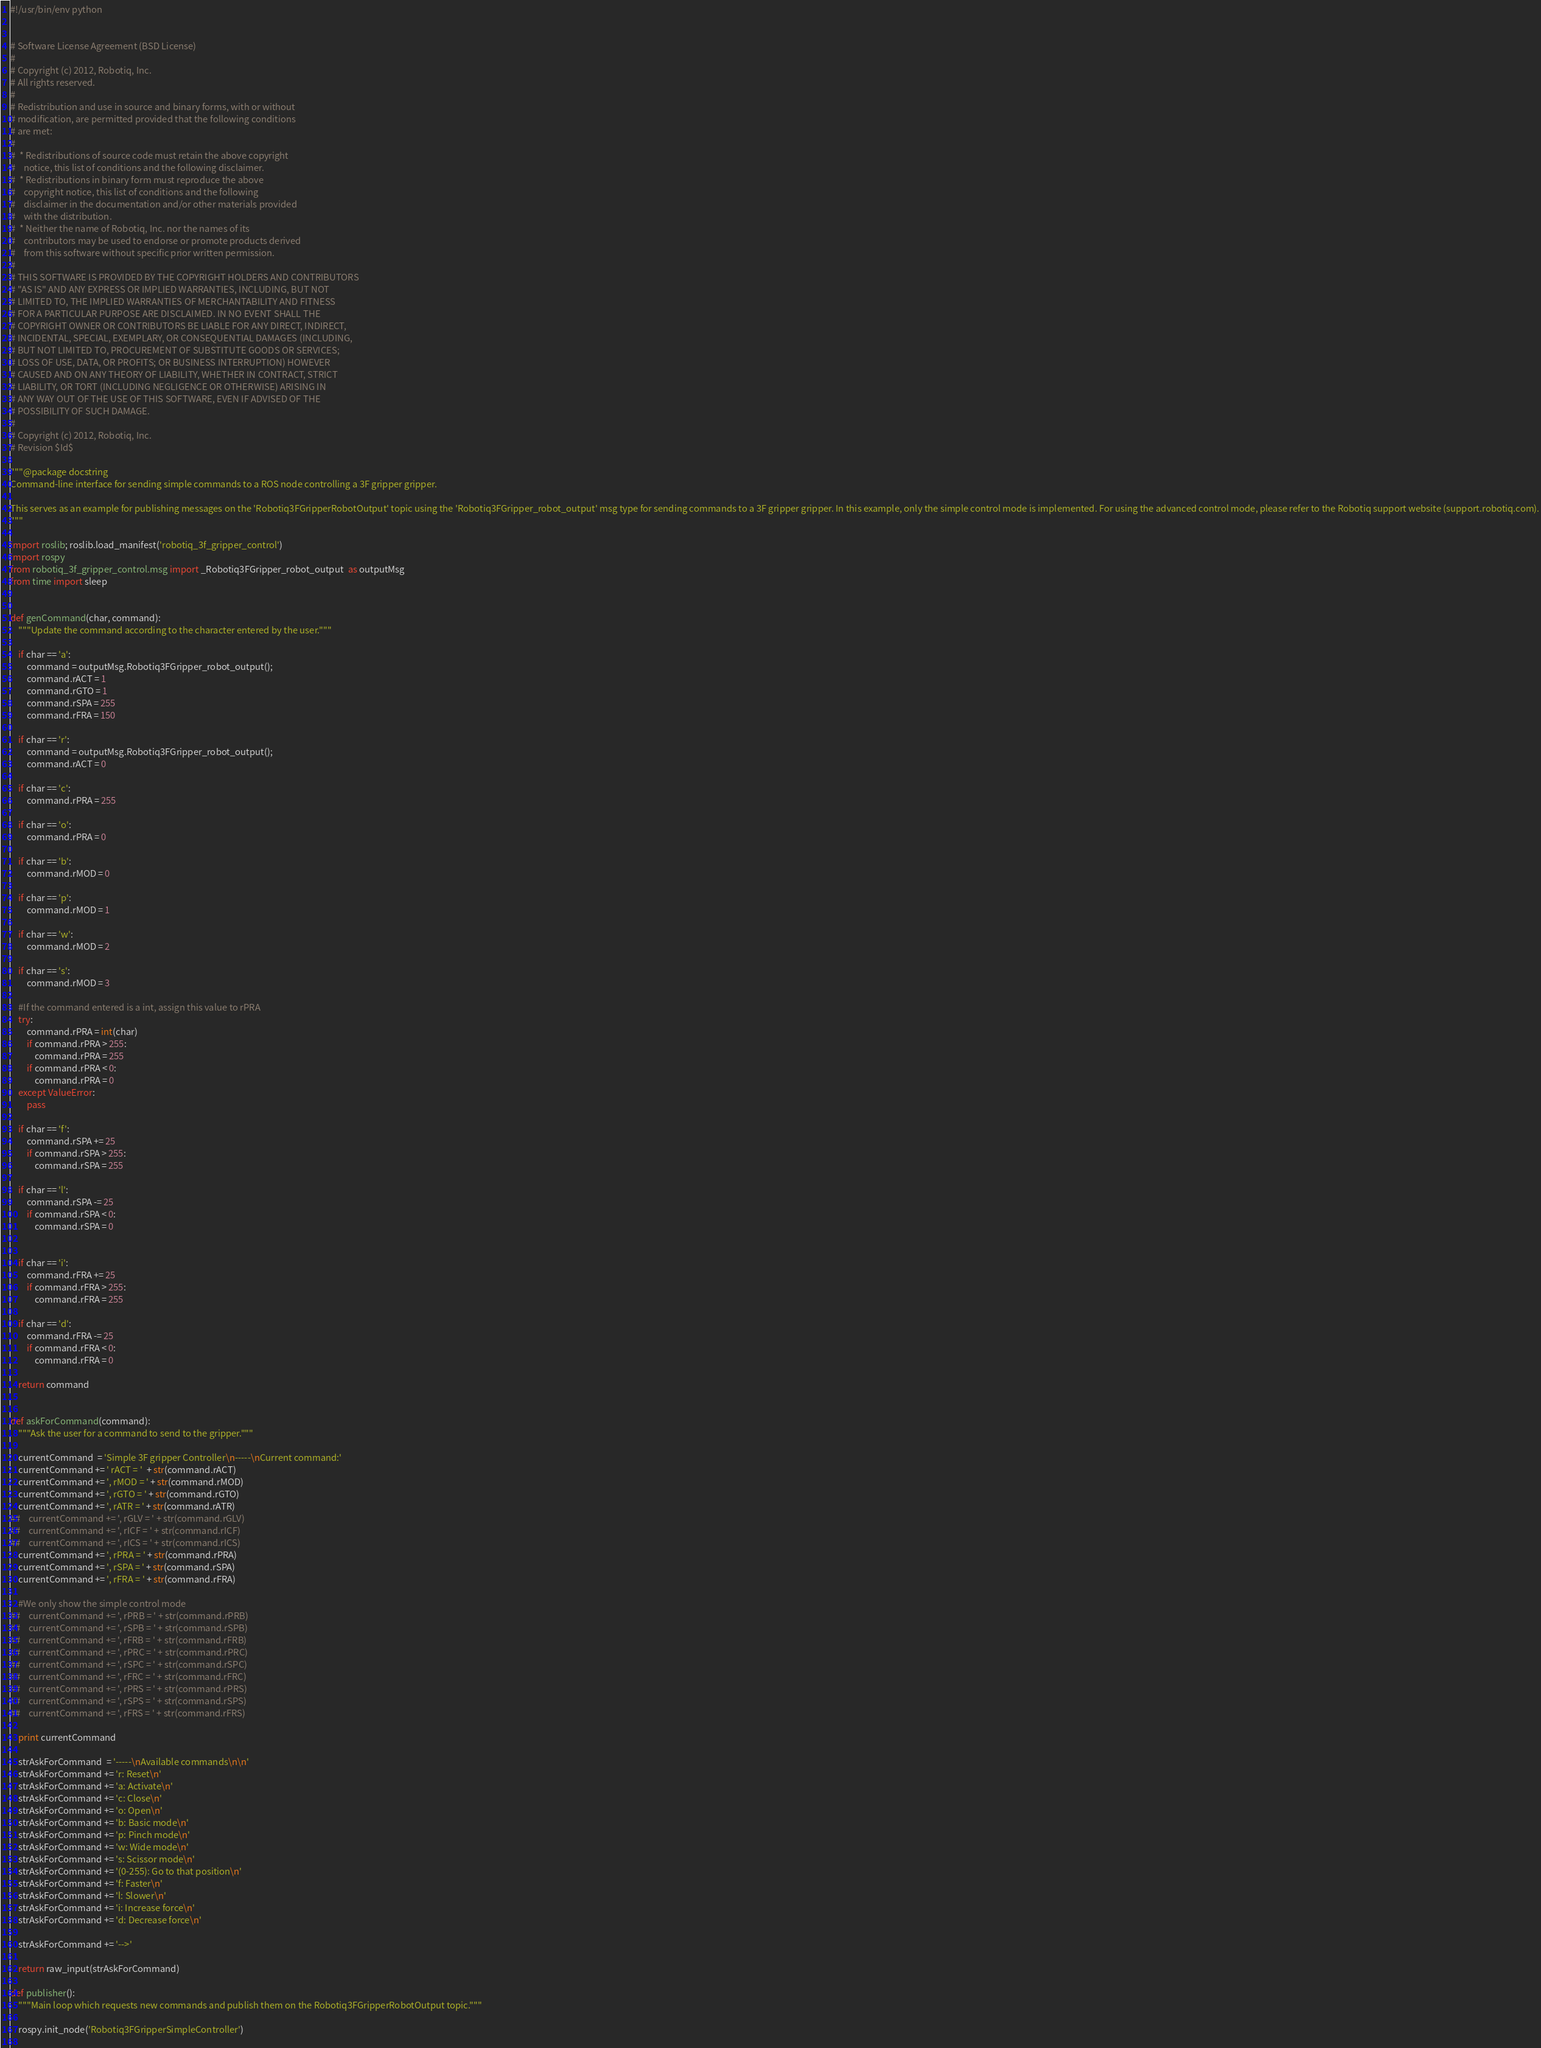Convert code to text. <code><loc_0><loc_0><loc_500><loc_500><_Python_>#!/usr/bin/env python


# Software License Agreement (BSD License)
#
# Copyright (c) 2012, Robotiq, Inc.
# All rights reserved.
#
# Redistribution and use in source and binary forms, with or without
# modification, are permitted provided that the following conditions
# are met:
#
#  * Redistributions of source code must retain the above copyright
#    notice, this list of conditions and the following disclaimer.
#  * Redistributions in binary form must reproduce the above
#    copyright notice, this list of conditions and the following
#    disclaimer in the documentation and/or other materials provided
#    with the distribution.
#  * Neither the name of Robotiq, Inc. nor the names of its
#    contributors may be used to endorse or promote products derived
#    from this software without specific prior written permission.
#
# THIS SOFTWARE IS PROVIDED BY THE COPYRIGHT HOLDERS AND CONTRIBUTORS
# "AS IS" AND ANY EXPRESS OR IMPLIED WARRANTIES, INCLUDING, BUT NOT
# LIMITED TO, THE IMPLIED WARRANTIES OF MERCHANTABILITY AND FITNESS
# FOR A PARTICULAR PURPOSE ARE DISCLAIMED. IN NO EVENT SHALL THE
# COPYRIGHT OWNER OR CONTRIBUTORS BE LIABLE FOR ANY DIRECT, INDIRECT,
# INCIDENTAL, SPECIAL, EXEMPLARY, OR CONSEQUENTIAL DAMAGES (INCLUDING,
# BUT NOT LIMITED TO, PROCUREMENT OF SUBSTITUTE GOODS OR SERVICES;
# LOSS OF USE, DATA, OR PROFITS; OR BUSINESS INTERRUPTION) HOWEVER
# CAUSED AND ON ANY THEORY OF LIABILITY, WHETHER IN CONTRACT, STRICT
# LIABILITY, OR TORT (INCLUDING NEGLIGENCE OR OTHERWISE) ARISING IN
# ANY WAY OUT OF THE USE OF THIS SOFTWARE, EVEN IF ADVISED OF THE
# POSSIBILITY OF SUCH DAMAGE.
#
# Copyright (c) 2012, Robotiq, Inc.
# Revision $Id$

"""@package docstring
Command-line interface for sending simple commands to a ROS node controlling a 3F gripper gripper.

This serves as an example for publishing messages on the 'Robotiq3FGripperRobotOutput' topic using the 'Robotiq3FGripper_robot_output' msg type for sending commands to a 3F gripper gripper. In this example, only the simple control mode is implemented. For using the advanced control mode, please refer to the Robotiq support website (support.robotiq.com).
"""

import roslib; roslib.load_manifest('robotiq_3f_gripper_control')
import rospy
from robotiq_3f_gripper_control.msg import _Robotiq3FGripper_robot_output  as outputMsg
from time import sleep


def genCommand(char, command):
    """Update the command according to the character entered by the user."""    
        
    if char == 'a':
        command = outputMsg.Robotiq3FGripper_robot_output();
        command.rACT = 1
        command.rGTO = 1
        command.rSPA = 255
        command.rFRA = 150

    if char == 'r':
        command = outputMsg.Robotiq3FGripper_robot_output();
        command.rACT = 0

    if char == 'c':
        command.rPRA = 255

    if char == 'o':
        command.rPRA = 0

    if char == 'b':
        command.rMOD = 0
        
    if char == 'p':
        command.rMOD = 1
        
    if char == 'w':
        command.rMOD = 2
        
    if char == 's':
        command.rMOD = 3

    #If the command entered is a int, assign this value to rPRA
    try: 
        command.rPRA = int(char)
        if command.rPRA > 255:
            command.rPRA = 255
        if command.rPRA < 0:
            command.rPRA = 0
    except ValueError:
        pass                    
        
    if char == 'f':
        command.rSPA += 25
        if command.rSPA > 255:
            command.rSPA = 255
            
    if char == 'l':
        command.rSPA -= 25
        if command.rSPA < 0:
            command.rSPA = 0

            
    if char == 'i':
        command.rFRA += 25
        if command.rFRA > 255:
            command.rFRA = 255
            
    if char == 'd':
        command.rFRA -= 25
        if command.rFRA < 0:
            command.rFRA = 0

    return command
        

def askForCommand(command):
    """Ask the user for a command to send to the gripper."""    

    currentCommand  = 'Simple 3F gripper Controller\n-----\nCurrent command:'
    currentCommand += ' rACT = '  + str(command.rACT)
    currentCommand += ', rMOD = ' + str(command.rMOD)
    currentCommand += ', rGTO = ' + str(command.rGTO)
    currentCommand += ', rATR = ' + str(command.rATR)
##    currentCommand += ', rGLV = ' + str(command.rGLV)
##    currentCommand += ', rICF = ' + str(command.rICF)
##    currentCommand += ', rICS = ' + str(command.rICS)
    currentCommand += ', rPRA = ' + str(command.rPRA)
    currentCommand += ', rSPA = ' + str(command.rSPA)
    currentCommand += ', rFRA = ' + str(command.rFRA)

    #We only show the simple control mode
##    currentCommand += ', rPRB = ' + str(command.rPRB)
##    currentCommand += ', rSPB = ' + str(command.rSPB)
##    currentCommand += ', rFRB = ' + str(command.rFRB)
##    currentCommand += ', rPRC = ' + str(command.rPRC)
##    currentCommand += ', rSPC = ' + str(command.rSPC)
##    currentCommand += ', rFRC = ' + str(command.rFRC)
##    currentCommand += ', rPRS = ' + str(command.rPRS)
##    currentCommand += ', rSPS = ' + str(command.rSPS)
##    currentCommand += ', rFRS = ' + str(command.rFRS)

    print currentCommand

    strAskForCommand  = '-----\nAvailable commands\n\n'
    strAskForCommand += 'r: Reset\n'
    strAskForCommand += 'a: Activate\n'
    strAskForCommand += 'c: Close\n'
    strAskForCommand += 'o: Open\n'
    strAskForCommand += 'b: Basic mode\n'
    strAskForCommand += 'p: Pinch mode\n'
    strAskForCommand += 'w: Wide mode\n'
    strAskForCommand += 's: Scissor mode\n'
    strAskForCommand += '(0-255): Go to that position\n'
    strAskForCommand += 'f: Faster\n'
    strAskForCommand += 'l: Slower\n'
    strAskForCommand += 'i: Increase force\n'
    strAskForCommand += 'd: Decrease force\n'
    
    strAskForCommand += '-->'

    return raw_input(strAskForCommand)

def publisher():
    """Main loop which requests new commands and publish them on the Robotiq3FGripperRobotOutput topic."""

    rospy.init_node('Robotiq3FGripperSimpleController')
    </code> 